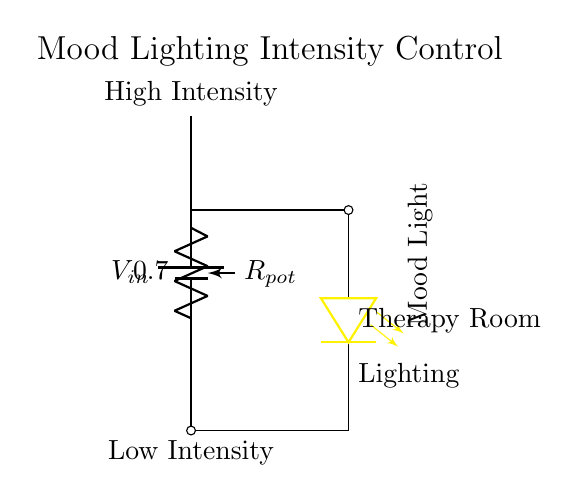What is the primary purpose of the circuit? The circuit is designed to control the intensity of mood lighting in a therapy room by utilizing a potentiometer to adjust the voltage supplied to the LED.
Answer: Mood lighting control What type of component is Rpot? Rpot is a potentiometer, which is a variable resistor that adjusts the resistance in the circuit to control the voltage output and thus the brightness of the LED.
Answer: Potentiometer How many leads does the LED have? The LED typically has two leads: an anode and a cathode, which are used to connect it in the circuit for proper operation.
Answer: Two What happens when the potentiometer is turned to a high resistance setting? When the potentiometer is set to a high resistance, it reduces the current flowing through the circuit, resulting in a lower brightness of the mood lighting.
Answer: Lower brightness What indication do the labels provide in the circuit? The labels "High Intensity" and "Low Intensity" indicate the adjustable range of the lighting as controlled by the potentiometer, showing the effect on brightness at each extreme.
Answer: Adjustable brightness In which region of the circuit is the LED located? The LED is located between the output of the potentiometer and ground, indicating that it receives the adjusted voltage to function as mood lighting.
Answer: Between potentiometer and ground What effect does adjusting Rpot have on Vout? Adjusting Rpot changes its resistance, which alters the voltage drop across it, thus varying the output voltage (Vout) that powers the LED and affects its brightness.
Answer: Varies output voltage 